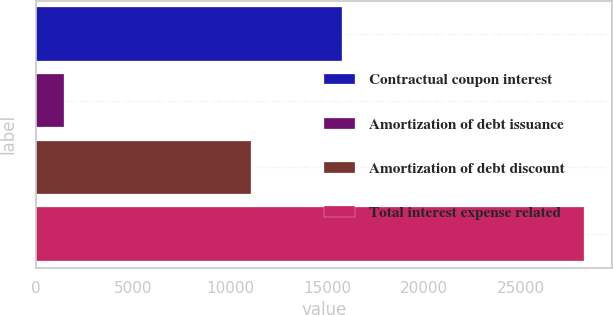Convert chart to OTSL. <chart><loc_0><loc_0><loc_500><loc_500><bar_chart><fcel>Contractual coupon interest<fcel>Amortization of debt issuance<fcel>Amortization of debt discount<fcel>Total interest expense related<nl><fcel>15750<fcel>1448<fcel>11052<fcel>28250<nl></chart> 